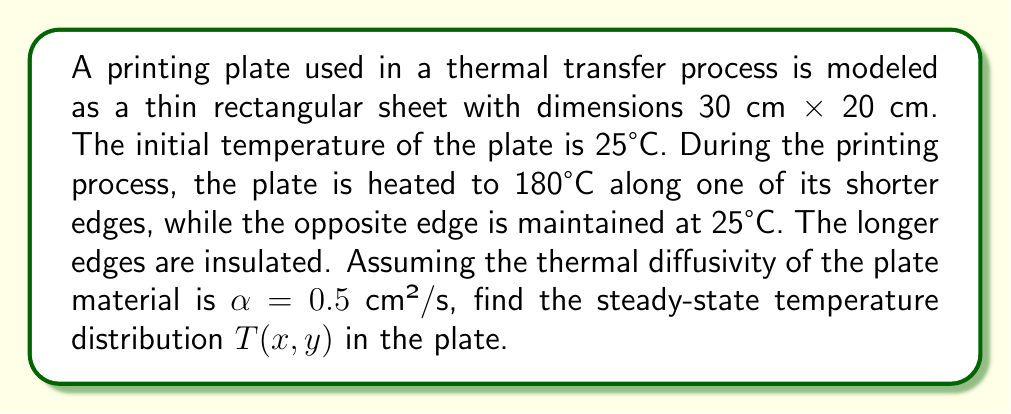Can you solve this math problem? To solve this problem, we need to use the steady-state heat equation in two dimensions:

$$\frac{\partial^2 T}{\partial x^2} + \frac{\partial^2 T}{\partial y^2} = 0$$

Given the boundary conditions:

1. $T(0,y) = 180°C$
2. $T(30,y) = 25°C$
3. $\frac{\partial T}{\partial y}(x,0) = \frac{\partial T}{\partial y}(x,20) = 0$

We can solve this using separation of variables. Let $T(x,y) = X(x)Y(y)$.

Substituting into the heat equation:

$$X''(x)Y(y) + X(x)Y''(y) = 0$$
$$\frac{X''(x)}{X(x)} = -\frac{Y''(y)}{Y(y)} = -\lambda^2$$

This gives us two ODEs:
$$X''(x) + \lambda^2 X(x) = 0$$
$$Y''(y) - \lambda^2 Y(y) = 0$$

The general solutions are:
$$X(x) = A \cos(\lambda x) + B \sin(\lambda x)$$
$$Y(y) = C e^{\lambda y} + D e^{-\lambda y}$$

Applying the boundary conditions for $Y(y)$:
$$Y'(0) = Y'(20) = 0 \implies C = D \text{ and } \lambda = \frac{n\pi}{20}, n = 0,1,2,...$$

For $X(x)$, we have:
$$X(0) = 180 \text{ and } X(30) = 25$$

The solution that satisfies these conditions is:

$$T(x,y) = 25 + 155 \frac{\sinh(\frac{\pi(30-x)}{20})}{\sinh(\frac{3\pi}{2})}$$

This represents the steady-state temperature distribution in the printing plate.
Answer: $T(x,y) = 25 + 155 \frac{\sinh(\frac{\pi(30-x)}{20})}{\sinh(\frac{3\pi}{2})}$ 